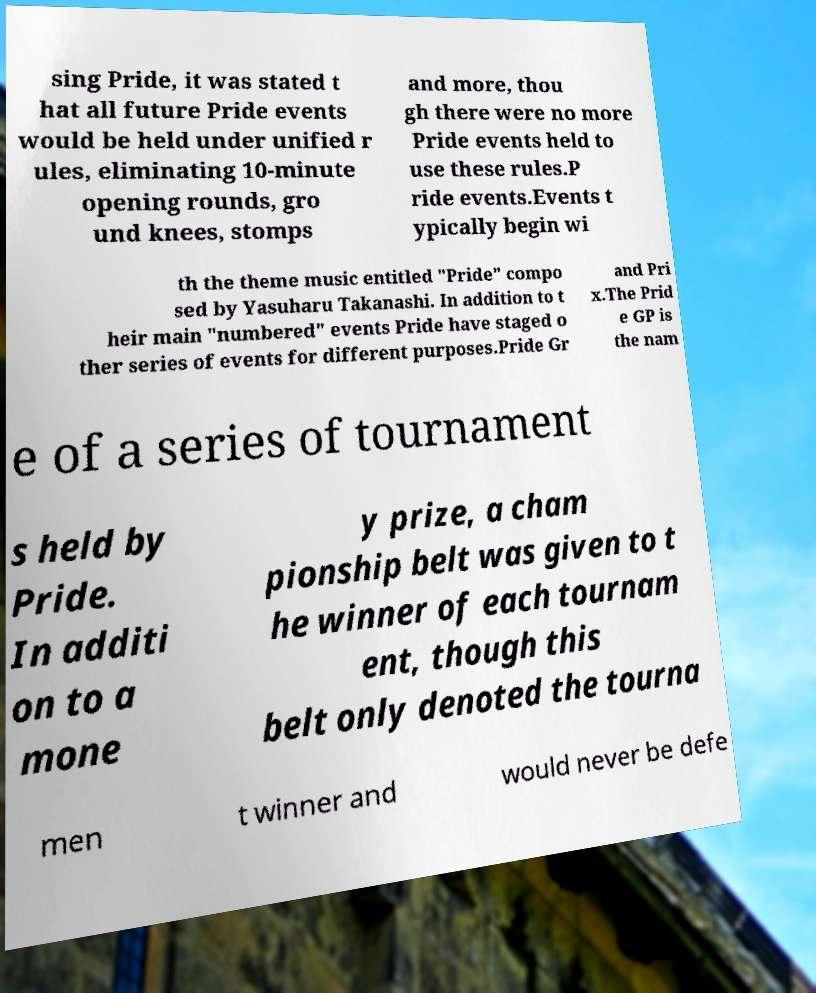Could you assist in decoding the text presented in this image and type it out clearly? sing Pride, it was stated t hat all future Pride events would be held under unified r ules, eliminating 10-minute opening rounds, gro und knees, stomps and more, thou gh there were no more Pride events held to use these rules.P ride events.Events t ypically begin wi th the theme music entitled "Pride" compo sed by Yasuharu Takanashi. In addition to t heir main "numbered" events Pride have staged o ther series of events for different purposes.Pride Gr and Pri x.The Prid e GP is the nam e of a series of tournament s held by Pride. In additi on to a mone y prize, a cham pionship belt was given to t he winner of each tournam ent, though this belt only denoted the tourna men t winner and would never be defe 